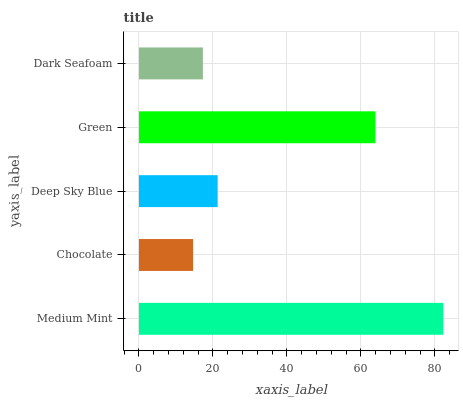Is Chocolate the minimum?
Answer yes or no. Yes. Is Medium Mint the maximum?
Answer yes or no. Yes. Is Deep Sky Blue the minimum?
Answer yes or no. No. Is Deep Sky Blue the maximum?
Answer yes or no. No. Is Deep Sky Blue greater than Chocolate?
Answer yes or no. Yes. Is Chocolate less than Deep Sky Blue?
Answer yes or no. Yes. Is Chocolate greater than Deep Sky Blue?
Answer yes or no. No. Is Deep Sky Blue less than Chocolate?
Answer yes or no. No. Is Deep Sky Blue the high median?
Answer yes or no. Yes. Is Deep Sky Blue the low median?
Answer yes or no. Yes. Is Green the high median?
Answer yes or no. No. Is Medium Mint the low median?
Answer yes or no. No. 